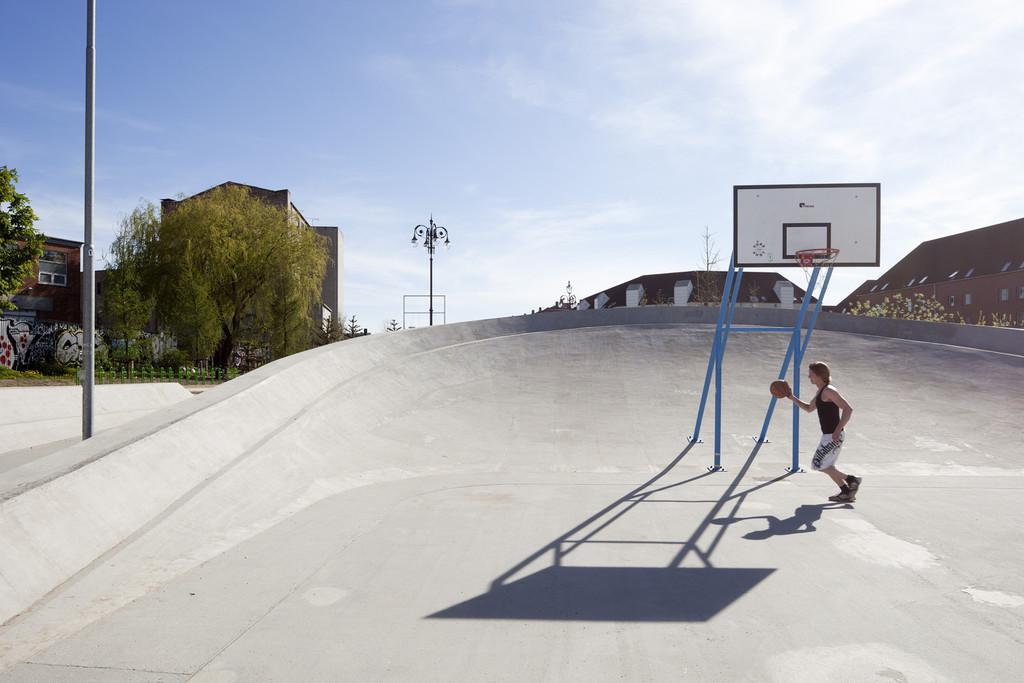What type of surface is visible in the image? There is a floor in the image. What sports equipment can be seen in the image? There is a basketball goal post in the image. What is the person in the image holding? The person is standing and holding a basketball in the image. What type of structures are present in the image? There are poles and buildings in the image. What type of vegetation is visible in the image? There are trees in the image. What is visible in the background of the image? The sky is visible in the background of the image. How many chickens are visible in the image? There are no chickens present in the image. What type of health advice can be seen on the basketball goal post in the image? There is no health advice visible on the basketball goal post in the image. 